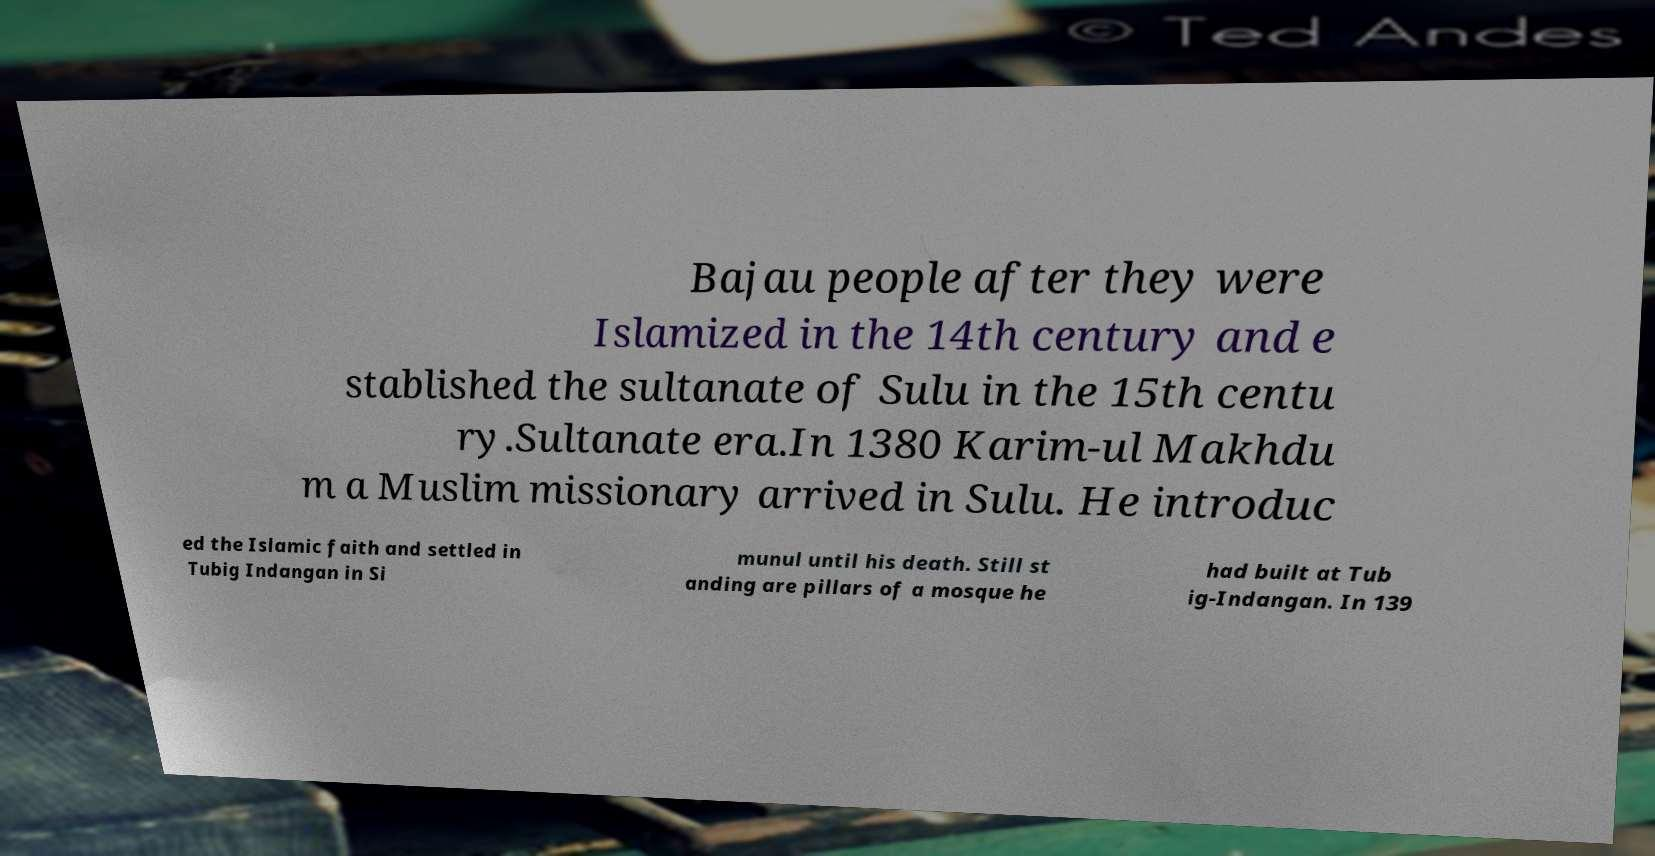Could you assist in decoding the text presented in this image and type it out clearly? Bajau people after they were Islamized in the 14th century and e stablished the sultanate of Sulu in the 15th centu ry.Sultanate era.In 1380 Karim-ul Makhdu m a Muslim missionary arrived in Sulu. He introduc ed the Islamic faith and settled in Tubig Indangan in Si munul until his death. Still st anding are pillars of a mosque he had built at Tub ig-Indangan. In 139 